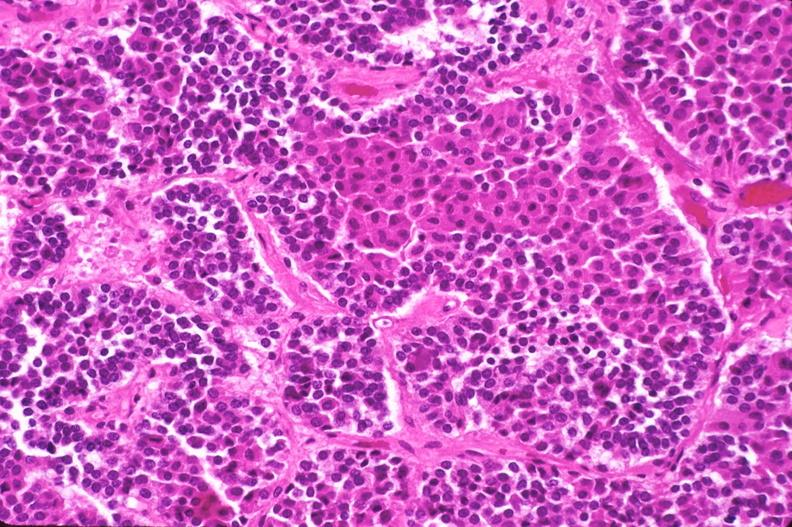where is this part in the figure?
Answer the question using a single word or phrase. Endocrine system 